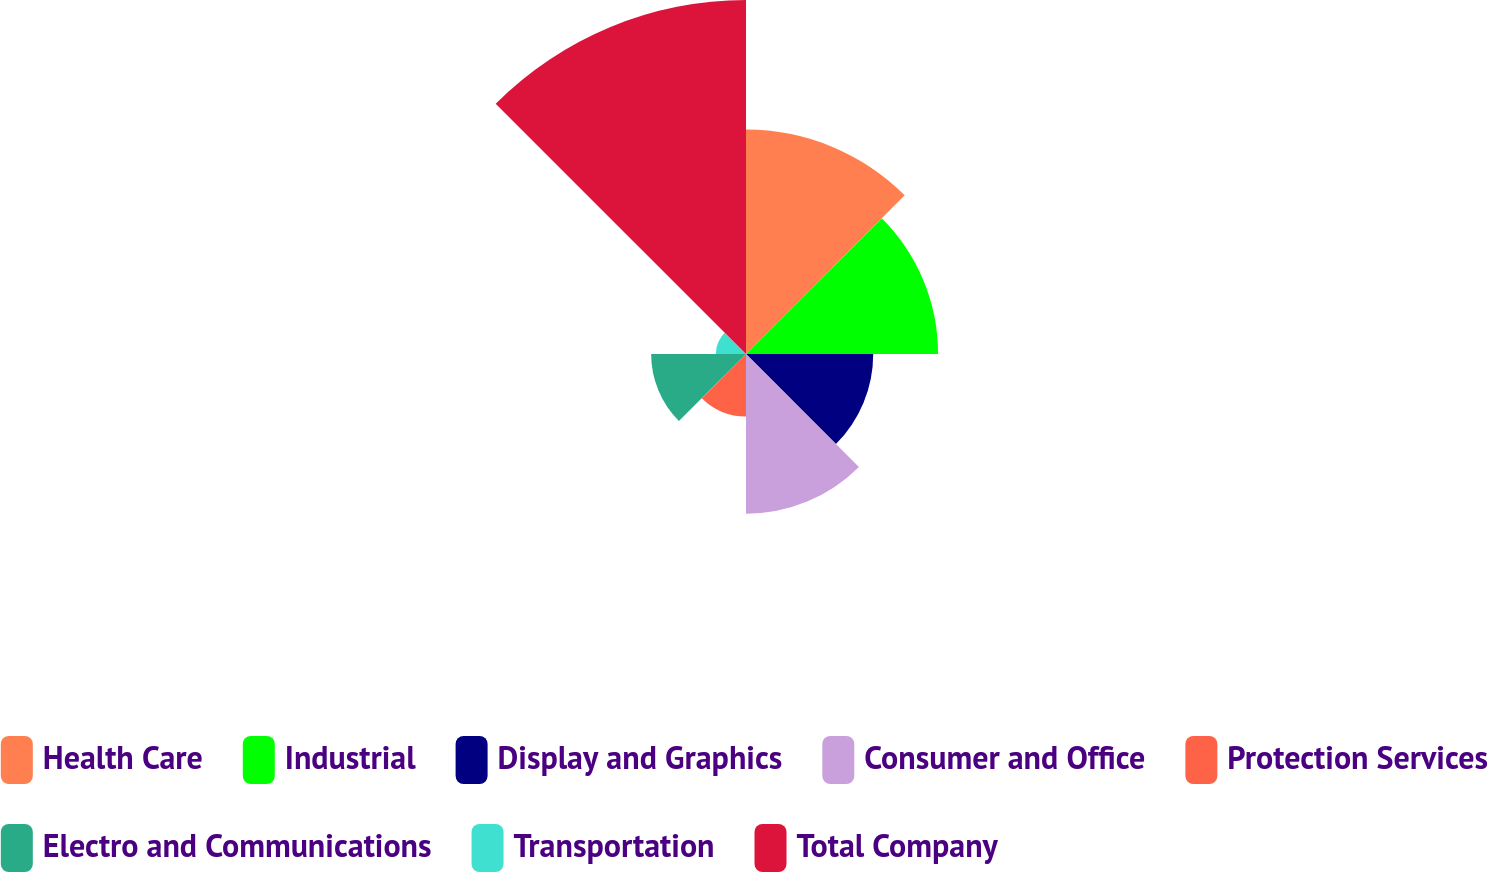Convert chart. <chart><loc_0><loc_0><loc_500><loc_500><pie_chart><fcel>Health Care<fcel>Industrial<fcel>Display and Graphics<fcel>Consumer and Office<fcel>Protection Services<fcel>Electro and Communications<fcel>Transportation<fcel>Total Company<nl><fcel>18.03%<fcel>15.43%<fcel>10.22%<fcel>12.83%<fcel>5.02%<fcel>7.62%<fcel>2.42%<fcel>28.44%<nl></chart> 